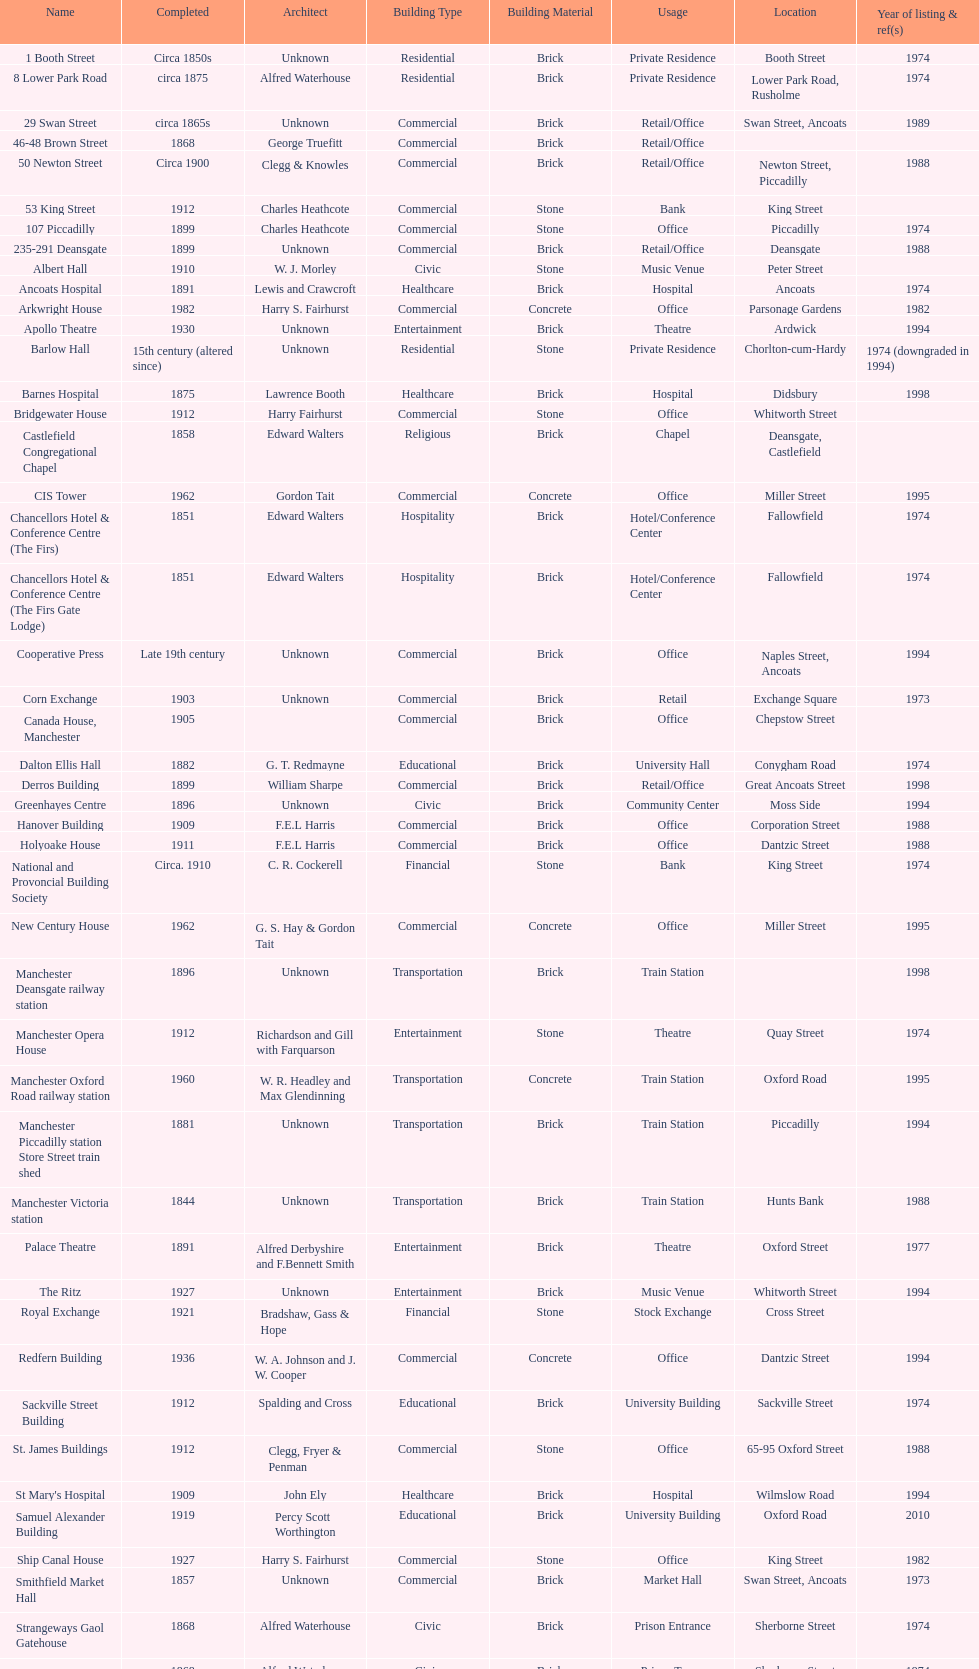How many buildings do not have an image listed? 11. 